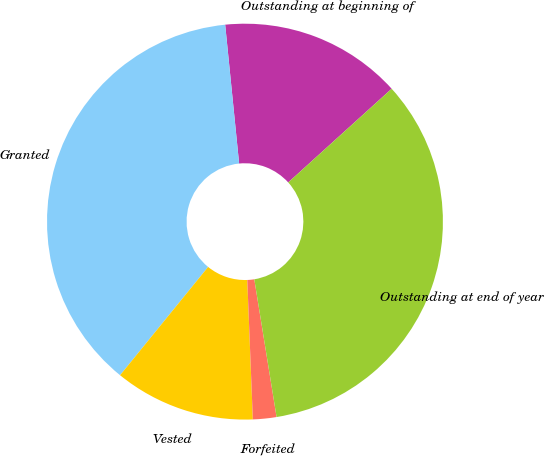Convert chart to OTSL. <chart><loc_0><loc_0><loc_500><loc_500><pie_chart><fcel>Outstanding at beginning of<fcel>Granted<fcel>Vested<fcel>Forfeited<fcel>Outstanding at end of year<nl><fcel>14.88%<fcel>37.54%<fcel>11.5%<fcel>1.92%<fcel>34.16%<nl></chart> 